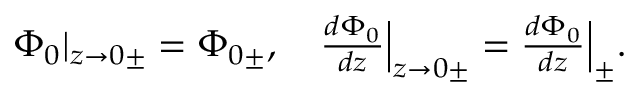<formula> <loc_0><loc_0><loc_500><loc_500>\begin{array} { r } { { \Phi } _ { 0 } | _ { z \to 0 \pm } = { \Phi } _ { 0 \pm } , \quad \frac { d { \Phi } _ { 0 } } { d z } \left | _ { z \to 0 \pm } = \frac { d { \Phi } _ { 0 } } { d z } \right | _ { \pm } . } \end{array}</formula> 